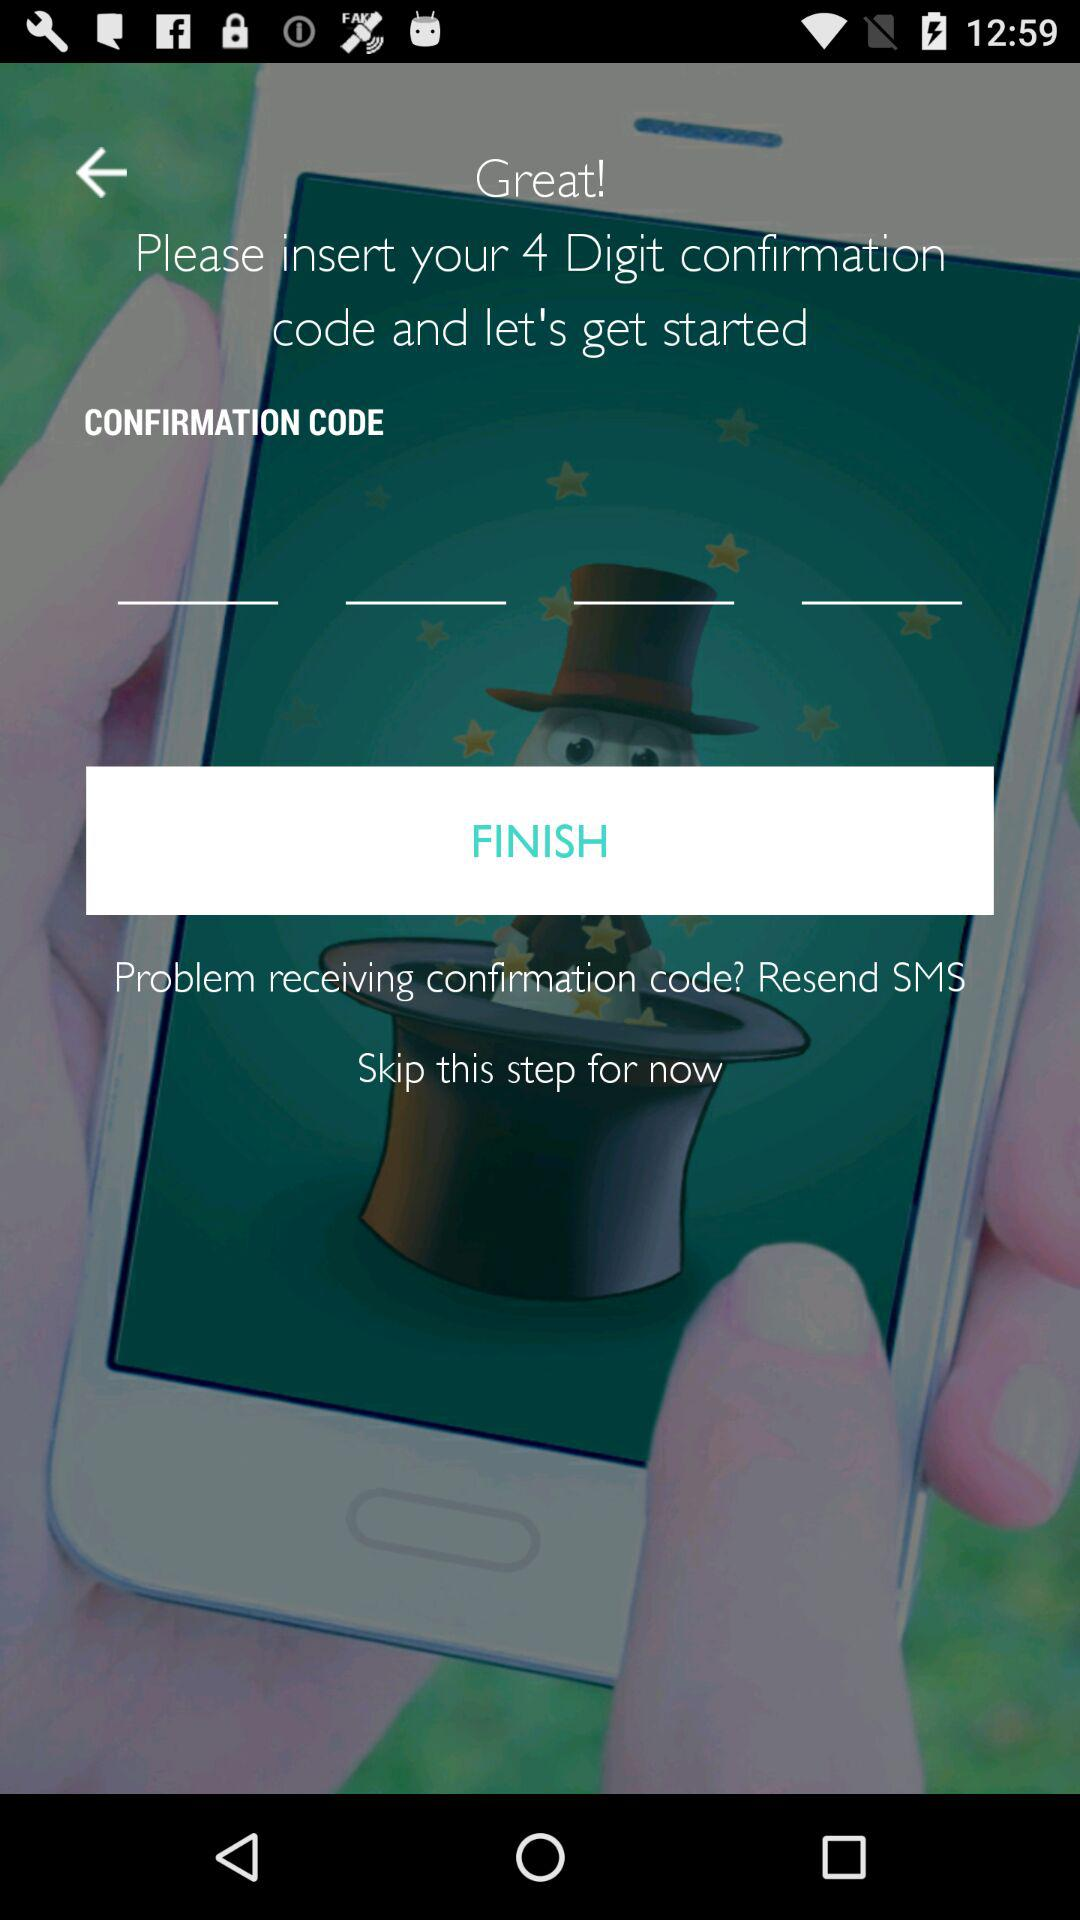How many text inputs are there for the confirmation code?
Answer the question using a single word or phrase. 4 